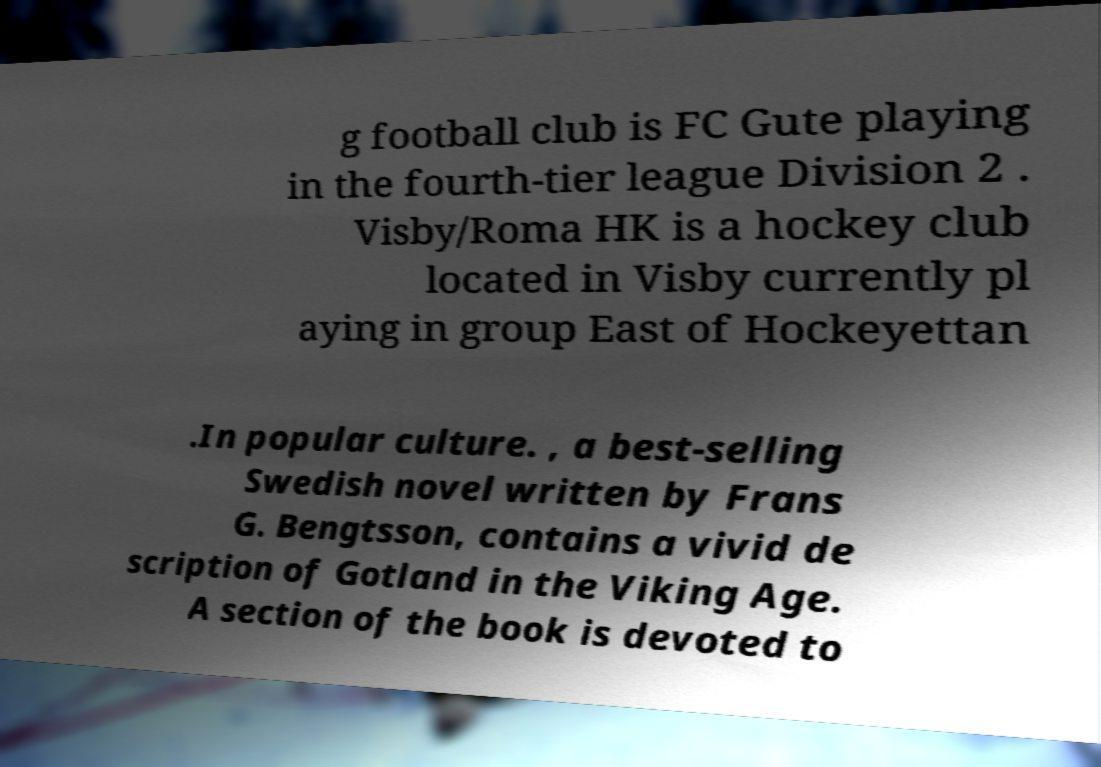Can you read and provide the text displayed in the image?This photo seems to have some interesting text. Can you extract and type it out for me? g football club is FC Gute playing in the fourth-tier league Division 2 . Visby/Roma HK is a hockey club located in Visby currently pl aying in group East of Hockeyettan .In popular culture. , a best-selling Swedish novel written by Frans G. Bengtsson, contains a vivid de scription of Gotland in the Viking Age. A section of the book is devoted to 